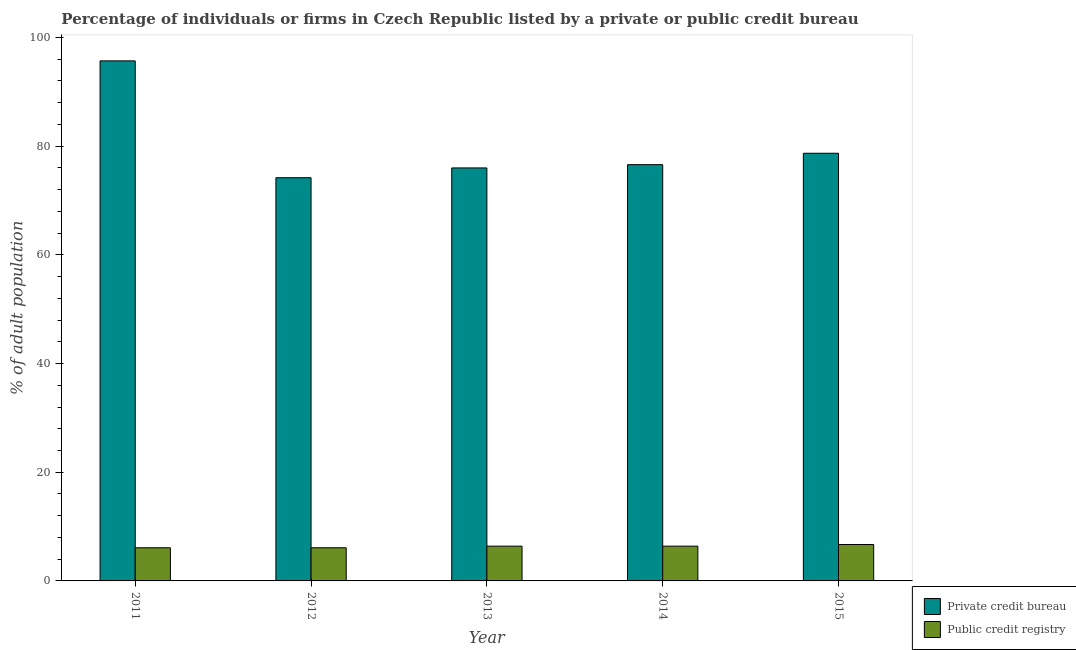How many groups of bars are there?
Offer a terse response. 5. How many bars are there on the 2nd tick from the left?
Provide a succinct answer. 2. How many bars are there on the 5th tick from the right?
Provide a succinct answer. 2. What is the label of the 5th group of bars from the left?
Ensure brevity in your answer.  2015. In how many cases, is the number of bars for a given year not equal to the number of legend labels?
Your answer should be compact. 0. Across all years, what is the minimum percentage of firms listed by private credit bureau?
Give a very brief answer. 74.2. In which year was the percentage of firms listed by public credit bureau maximum?
Provide a succinct answer. 2015. What is the total percentage of firms listed by public credit bureau in the graph?
Provide a succinct answer. 31.7. What is the difference between the percentage of firms listed by private credit bureau in 2014 and that in 2015?
Offer a very short reply. -2.1. What is the difference between the percentage of firms listed by private credit bureau in 2011 and the percentage of firms listed by public credit bureau in 2015?
Make the answer very short. 17. What is the average percentage of firms listed by public credit bureau per year?
Keep it short and to the point. 6.34. In how many years, is the percentage of firms listed by public credit bureau greater than 8 %?
Ensure brevity in your answer.  0. What is the ratio of the percentage of firms listed by private credit bureau in 2012 to that in 2013?
Provide a succinct answer. 0.98. What is the difference between the highest and the second highest percentage of firms listed by public credit bureau?
Provide a succinct answer. 0.3. What is the difference between the highest and the lowest percentage of firms listed by private credit bureau?
Keep it short and to the point. 21.5. What does the 2nd bar from the left in 2015 represents?
Your answer should be compact. Public credit registry. What does the 2nd bar from the right in 2012 represents?
Ensure brevity in your answer.  Private credit bureau. Are the values on the major ticks of Y-axis written in scientific E-notation?
Your response must be concise. No. Does the graph contain grids?
Your answer should be very brief. No. How many legend labels are there?
Make the answer very short. 2. How are the legend labels stacked?
Give a very brief answer. Vertical. What is the title of the graph?
Give a very brief answer. Percentage of individuals or firms in Czech Republic listed by a private or public credit bureau. Does "Males" appear as one of the legend labels in the graph?
Keep it short and to the point. No. What is the label or title of the X-axis?
Your answer should be very brief. Year. What is the label or title of the Y-axis?
Offer a terse response. % of adult population. What is the % of adult population in Private credit bureau in 2011?
Offer a terse response. 95.7. What is the % of adult population of Private credit bureau in 2012?
Offer a terse response. 74.2. What is the % of adult population in Private credit bureau in 2013?
Your answer should be very brief. 76. What is the % of adult population in Public credit registry in 2013?
Provide a succinct answer. 6.4. What is the % of adult population in Private credit bureau in 2014?
Keep it short and to the point. 76.6. What is the % of adult population of Private credit bureau in 2015?
Make the answer very short. 78.7. What is the % of adult population of Public credit registry in 2015?
Offer a very short reply. 6.7. Across all years, what is the maximum % of adult population in Private credit bureau?
Make the answer very short. 95.7. Across all years, what is the maximum % of adult population of Public credit registry?
Make the answer very short. 6.7. Across all years, what is the minimum % of adult population of Private credit bureau?
Give a very brief answer. 74.2. What is the total % of adult population of Private credit bureau in the graph?
Your response must be concise. 401.2. What is the total % of adult population in Public credit registry in the graph?
Your answer should be compact. 31.7. What is the difference between the % of adult population in Public credit registry in 2011 and that in 2012?
Make the answer very short. 0. What is the difference between the % of adult population of Public credit registry in 2011 and that in 2013?
Ensure brevity in your answer.  -0.3. What is the difference between the % of adult population in Public credit registry in 2011 and that in 2014?
Provide a succinct answer. -0.3. What is the difference between the % of adult population in Public credit registry in 2012 and that in 2013?
Provide a short and direct response. -0.3. What is the difference between the % of adult population of Private credit bureau in 2012 and that in 2014?
Provide a short and direct response. -2.4. What is the difference between the % of adult population of Private credit bureau in 2012 and that in 2015?
Give a very brief answer. -4.5. What is the difference between the % of adult population of Public credit registry in 2012 and that in 2015?
Make the answer very short. -0.6. What is the difference between the % of adult population of Private credit bureau in 2013 and that in 2014?
Give a very brief answer. -0.6. What is the difference between the % of adult population in Private credit bureau in 2013 and that in 2015?
Give a very brief answer. -2.7. What is the difference between the % of adult population in Private credit bureau in 2011 and the % of adult population in Public credit registry in 2012?
Offer a very short reply. 89.6. What is the difference between the % of adult population of Private credit bureau in 2011 and the % of adult population of Public credit registry in 2013?
Offer a terse response. 89.3. What is the difference between the % of adult population in Private credit bureau in 2011 and the % of adult population in Public credit registry in 2014?
Your answer should be very brief. 89.3. What is the difference between the % of adult population of Private credit bureau in 2011 and the % of adult population of Public credit registry in 2015?
Provide a short and direct response. 89. What is the difference between the % of adult population in Private credit bureau in 2012 and the % of adult population in Public credit registry in 2013?
Your answer should be compact. 67.8. What is the difference between the % of adult population in Private credit bureau in 2012 and the % of adult population in Public credit registry in 2014?
Your response must be concise. 67.8. What is the difference between the % of adult population in Private credit bureau in 2012 and the % of adult population in Public credit registry in 2015?
Give a very brief answer. 67.5. What is the difference between the % of adult population in Private credit bureau in 2013 and the % of adult population in Public credit registry in 2014?
Your answer should be compact. 69.6. What is the difference between the % of adult population of Private credit bureau in 2013 and the % of adult population of Public credit registry in 2015?
Ensure brevity in your answer.  69.3. What is the difference between the % of adult population of Private credit bureau in 2014 and the % of adult population of Public credit registry in 2015?
Give a very brief answer. 69.9. What is the average % of adult population in Private credit bureau per year?
Your answer should be compact. 80.24. What is the average % of adult population in Public credit registry per year?
Your answer should be compact. 6.34. In the year 2011, what is the difference between the % of adult population in Private credit bureau and % of adult population in Public credit registry?
Your answer should be very brief. 89.6. In the year 2012, what is the difference between the % of adult population of Private credit bureau and % of adult population of Public credit registry?
Provide a short and direct response. 68.1. In the year 2013, what is the difference between the % of adult population of Private credit bureau and % of adult population of Public credit registry?
Your answer should be compact. 69.6. In the year 2014, what is the difference between the % of adult population of Private credit bureau and % of adult population of Public credit registry?
Ensure brevity in your answer.  70.2. What is the ratio of the % of adult population of Private credit bureau in 2011 to that in 2012?
Offer a terse response. 1.29. What is the ratio of the % of adult population in Private credit bureau in 2011 to that in 2013?
Provide a short and direct response. 1.26. What is the ratio of the % of adult population of Public credit registry in 2011 to that in 2013?
Your response must be concise. 0.95. What is the ratio of the % of adult population of Private credit bureau in 2011 to that in 2014?
Provide a short and direct response. 1.25. What is the ratio of the % of adult population in Public credit registry in 2011 to that in 2014?
Provide a short and direct response. 0.95. What is the ratio of the % of adult population in Private credit bureau in 2011 to that in 2015?
Your response must be concise. 1.22. What is the ratio of the % of adult population in Public credit registry in 2011 to that in 2015?
Offer a very short reply. 0.91. What is the ratio of the % of adult population of Private credit bureau in 2012 to that in 2013?
Provide a succinct answer. 0.98. What is the ratio of the % of adult population of Public credit registry in 2012 to that in 2013?
Your answer should be compact. 0.95. What is the ratio of the % of adult population of Private credit bureau in 2012 to that in 2014?
Your response must be concise. 0.97. What is the ratio of the % of adult population of Public credit registry in 2012 to that in 2014?
Give a very brief answer. 0.95. What is the ratio of the % of adult population of Private credit bureau in 2012 to that in 2015?
Provide a short and direct response. 0.94. What is the ratio of the % of adult population of Public credit registry in 2012 to that in 2015?
Your answer should be very brief. 0.91. What is the ratio of the % of adult population in Public credit registry in 2013 to that in 2014?
Keep it short and to the point. 1. What is the ratio of the % of adult population in Private credit bureau in 2013 to that in 2015?
Keep it short and to the point. 0.97. What is the ratio of the % of adult population of Public credit registry in 2013 to that in 2015?
Your answer should be very brief. 0.96. What is the ratio of the % of adult population in Private credit bureau in 2014 to that in 2015?
Your answer should be compact. 0.97. What is the ratio of the % of adult population of Public credit registry in 2014 to that in 2015?
Provide a succinct answer. 0.96. What is the difference between the highest and the lowest % of adult population in Private credit bureau?
Ensure brevity in your answer.  21.5. What is the difference between the highest and the lowest % of adult population in Public credit registry?
Provide a short and direct response. 0.6. 